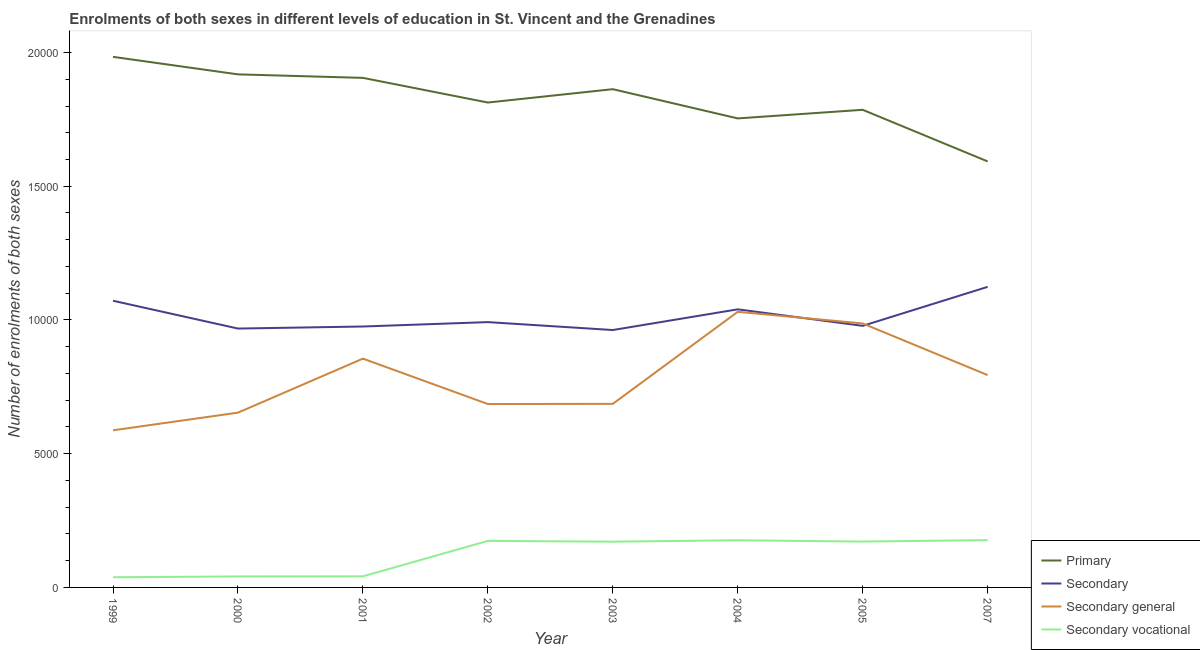How many different coloured lines are there?
Offer a terse response. 4. Does the line corresponding to number of enrolments in primary education intersect with the line corresponding to number of enrolments in secondary general education?
Offer a very short reply. No. What is the number of enrolments in secondary education in 1999?
Provide a succinct answer. 1.07e+04. Across all years, what is the maximum number of enrolments in primary education?
Make the answer very short. 1.98e+04. Across all years, what is the minimum number of enrolments in secondary vocational education?
Your answer should be compact. 380. In which year was the number of enrolments in secondary general education maximum?
Ensure brevity in your answer.  2004. In which year was the number of enrolments in secondary vocational education minimum?
Make the answer very short. 1999. What is the total number of enrolments in primary education in the graph?
Offer a very short reply. 1.46e+05. What is the difference between the number of enrolments in primary education in 2004 and that in 2005?
Your answer should be compact. -322. What is the difference between the number of enrolments in secondary general education in 2002 and the number of enrolments in primary education in 2004?
Your response must be concise. -1.07e+04. What is the average number of enrolments in secondary education per year?
Provide a short and direct response. 1.01e+04. In the year 2000, what is the difference between the number of enrolments in primary education and number of enrolments in secondary general education?
Your answer should be very brief. 1.26e+04. In how many years, is the number of enrolments in primary education greater than 4000?
Make the answer very short. 8. What is the ratio of the number of enrolments in secondary general education in 1999 to that in 2000?
Offer a very short reply. 0.9. What is the difference between the highest and the second highest number of enrolments in primary education?
Your response must be concise. 655. What is the difference between the highest and the lowest number of enrolments in secondary general education?
Your answer should be very brief. 4430. In how many years, is the number of enrolments in secondary general education greater than the average number of enrolments in secondary general education taken over all years?
Provide a succinct answer. 4. Is the sum of the number of enrolments in primary education in 1999 and 2004 greater than the maximum number of enrolments in secondary education across all years?
Provide a succinct answer. Yes. Is it the case that in every year, the sum of the number of enrolments in primary education and number of enrolments in secondary education is greater than the number of enrolments in secondary general education?
Your answer should be compact. Yes. Does the number of enrolments in primary education monotonically increase over the years?
Give a very brief answer. No. How many years are there in the graph?
Offer a very short reply. 8. Does the graph contain any zero values?
Keep it short and to the point. No. Does the graph contain grids?
Ensure brevity in your answer.  No. How many legend labels are there?
Your response must be concise. 4. What is the title of the graph?
Offer a very short reply. Enrolments of both sexes in different levels of education in St. Vincent and the Grenadines. Does "Negligence towards children" appear as one of the legend labels in the graph?
Provide a short and direct response. No. What is the label or title of the Y-axis?
Provide a succinct answer. Number of enrolments of both sexes. What is the Number of enrolments of both sexes of Primary in 1999?
Offer a terse response. 1.98e+04. What is the Number of enrolments of both sexes of Secondary in 1999?
Make the answer very short. 1.07e+04. What is the Number of enrolments of both sexes in Secondary general in 1999?
Offer a terse response. 5875. What is the Number of enrolments of both sexes of Secondary vocational in 1999?
Keep it short and to the point. 380. What is the Number of enrolments of both sexes of Primary in 2000?
Your answer should be compact. 1.92e+04. What is the Number of enrolments of both sexes of Secondary in 2000?
Your answer should be very brief. 9679. What is the Number of enrolments of both sexes in Secondary general in 2000?
Your response must be concise. 6535. What is the Number of enrolments of both sexes in Secondary vocational in 2000?
Provide a short and direct response. 411. What is the Number of enrolments of both sexes of Primary in 2001?
Your response must be concise. 1.91e+04. What is the Number of enrolments of both sexes of Secondary in 2001?
Offer a very short reply. 9756. What is the Number of enrolments of both sexes in Secondary general in 2001?
Make the answer very short. 8555. What is the Number of enrolments of both sexes in Secondary vocational in 2001?
Provide a short and direct response. 414. What is the Number of enrolments of both sexes of Primary in 2002?
Your answer should be very brief. 1.81e+04. What is the Number of enrolments of both sexes in Secondary in 2002?
Provide a succinct answer. 9920. What is the Number of enrolments of both sexes in Secondary general in 2002?
Keep it short and to the point. 6857. What is the Number of enrolments of both sexes of Secondary vocational in 2002?
Give a very brief answer. 1740. What is the Number of enrolments of both sexes in Primary in 2003?
Ensure brevity in your answer.  1.86e+04. What is the Number of enrolments of both sexes of Secondary in 2003?
Provide a short and direct response. 9624. What is the Number of enrolments of both sexes in Secondary general in 2003?
Offer a very short reply. 6864. What is the Number of enrolments of both sexes of Secondary vocational in 2003?
Give a very brief answer. 1711. What is the Number of enrolments of both sexes in Primary in 2004?
Your response must be concise. 1.75e+04. What is the Number of enrolments of both sexes in Secondary in 2004?
Ensure brevity in your answer.  1.04e+04. What is the Number of enrolments of both sexes in Secondary general in 2004?
Ensure brevity in your answer.  1.03e+04. What is the Number of enrolments of both sexes in Secondary vocational in 2004?
Provide a short and direct response. 1763. What is the Number of enrolments of both sexes in Primary in 2005?
Ensure brevity in your answer.  1.79e+04. What is the Number of enrolments of both sexes of Secondary in 2005?
Your answer should be compact. 9780. What is the Number of enrolments of both sexes in Secondary general in 2005?
Your answer should be compact. 9870. What is the Number of enrolments of both sexes in Secondary vocational in 2005?
Offer a terse response. 1715. What is the Number of enrolments of both sexes of Primary in 2007?
Offer a terse response. 1.59e+04. What is the Number of enrolments of both sexes in Secondary in 2007?
Your response must be concise. 1.12e+04. What is the Number of enrolments of both sexes of Secondary general in 2007?
Provide a succinct answer. 7939. What is the Number of enrolments of both sexes in Secondary vocational in 2007?
Ensure brevity in your answer.  1769. Across all years, what is the maximum Number of enrolments of both sexes in Primary?
Provide a short and direct response. 1.98e+04. Across all years, what is the maximum Number of enrolments of both sexes in Secondary?
Offer a terse response. 1.12e+04. Across all years, what is the maximum Number of enrolments of both sexes of Secondary general?
Provide a short and direct response. 1.03e+04. Across all years, what is the maximum Number of enrolments of both sexes in Secondary vocational?
Give a very brief answer. 1769. Across all years, what is the minimum Number of enrolments of both sexes of Primary?
Provide a succinct answer. 1.59e+04. Across all years, what is the minimum Number of enrolments of both sexes in Secondary?
Give a very brief answer. 9624. Across all years, what is the minimum Number of enrolments of both sexes of Secondary general?
Your response must be concise. 5875. Across all years, what is the minimum Number of enrolments of both sexes of Secondary vocational?
Give a very brief answer. 380. What is the total Number of enrolments of both sexes in Primary in the graph?
Provide a short and direct response. 1.46e+05. What is the total Number of enrolments of both sexes of Secondary in the graph?
Provide a succinct answer. 8.11e+04. What is the total Number of enrolments of both sexes in Secondary general in the graph?
Provide a short and direct response. 6.28e+04. What is the total Number of enrolments of both sexes in Secondary vocational in the graph?
Ensure brevity in your answer.  9903. What is the difference between the Number of enrolments of both sexes in Primary in 1999 and that in 2000?
Make the answer very short. 655. What is the difference between the Number of enrolments of both sexes in Secondary in 1999 and that in 2000?
Give a very brief answer. 1040. What is the difference between the Number of enrolments of both sexes of Secondary general in 1999 and that in 2000?
Offer a terse response. -660. What is the difference between the Number of enrolments of both sexes in Secondary vocational in 1999 and that in 2000?
Provide a short and direct response. -31. What is the difference between the Number of enrolments of both sexes of Primary in 1999 and that in 2001?
Make the answer very short. 786. What is the difference between the Number of enrolments of both sexes of Secondary in 1999 and that in 2001?
Provide a short and direct response. 963. What is the difference between the Number of enrolments of both sexes of Secondary general in 1999 and that in 2001?
Your answer should be compact. -2680. What is the difference between the Number of enrolments of both sexes in Secondary vocational in 1999 and that in 2001?
Give a very brief answer. -34. What is the difference between the Number of enrolments of both sexes of Primary in 1999 and that in 2002?
Offer a very short reply. 1708. What is the difference between the Number of enrolments of both sexes in Secondary in 1999 and that in 2002?
Your answer should be compact. 799. What is the difference between the Number of enrolments of both sexes of Secondary general in 1999 and that in 2002?
Provide a short and direct response. -982. What is the difference between the Number of enrolments of both sexes in Secondary vocational in 1999 and that in 2002?
Ensure brevity in your answer.  -1360. What is the difference between the Number of enrolments of both sexes in Primary in 1999 and that in 2003?
Ensure brevity in your answer.  1209. What is the difference between the Number of enrolments of both sexes of Secondary in 1999 and that in 2003?
Give a very brief answer. 1095. What is the difference between the Number of enrolments of both sexes of Secondary general in 1999 and that in 2003?
Offer a very short reply. -989. What is the difference between the Number of enrolments of both sexes in Secondary vocational in 1999 and that in 2003?
Provide a short and direct response. -1331. What is the difference between the Number of enrolments of both sexes in Primary in 1999 and that in 2004?
Ensure brevity in your answer.  2302. What is the difference between the Number of enrolments of both sexes in Secondary in 1999 and that in 2004?
Your response must be concise. 321. What is the difference between the Number of enrolments of both sexes in Secondary general in 1999 and that in 2004?
Give a very brief answer. -4430. What is the difference between the Number of enrolments of both sexes in Secondary vocational in 1999 and that in 2004?
Keep it short and to the point. -1383. What is the difference between the Number of enrolments of both sexes in Primary in 1999 and that in 2005?
Give a very brief answer. 1980. What is the difference between the Number of enrolments of both sexes in Secondary in 1999 and that in 2005?
Keep it short and to the point. 939. What is the difference between the Number of enrolments of both sexes in Secondary general in 1999 and that in 2005?
Provide a short and direct response. -3995. What is the difference between the Number of enrolments of both sexes of Secondary vocational in 1999 and that in 2005?
Offer a very short reply. -1335. What is the difference between the Number of enrolments of both sexes in Primary in 1999 and that in 2007?
Your response must be concise. 3910. What is the difference between the Number of enrolments of both sexes of Secondary in 1999 and that in 2007?
Offer a very short reply. -519. What is the difference between the Number of enrolments of both sexes in Secondary general in 1999 and that in 2007?
Keep it short and to the point. -2064. What is the difference between the Number of enrolments of both sexes of Secondary vocational in 1999 and that in 2007?
Give a very brief answer. -1389. What is the difference between the Number of enrolments of both sexes in Primary in 2000 and that in 2001?
Your answer should be compact. 131. What is the difference between the Number of enrolments of both sexes in Secondary in 2000 and that in 2001?
Your answer should be very brief. -77. What is the difference between the Number of enrolments of both sexes in Secondary general in 2000 and that in 2001?
Ensure brevity in your answer.  -2020. What is the difference between the Number of enrolments of both sexes in Secondary vocational in 2000 and that in 2001?
Give a very brief answer. -3. What is the difference between the Number of enrolments of both sexes in Primary in 2000 and that in 2002?
Give a very brief answer. 1053. What is the difference between the Number of enrolments of both sexes in Secondary in 2000 and that in 2002?
Your answer should be compact. -241. What is the difference between the Number of enrolments of both sexes in Secondary general in 2000 and that in 2002?
Keep it short and to the point. -322. What is the difference between the Number of enrolments of both sexes of Secondary vocational in 2000 and that in 2002?
Your response must be concise. -1329. What is the difference between the Number of enrolments of both sexes of Primary in 2000 and that in 2003?
Offer a very short reply. 554. What is the difference between the Number of enrolments of both sexes in Secondary in 2000 and that in 2003?
Provide a short and direct response. 55. What is the difference between the Number of enrolments of both sexes of Secondary general in 2000 and that in 2003?
Ensure brevity in your answer.  -329. What is the difference between the Number of enrolments of both sexes of Secondary vocational in 2000 and that in 2003?
Provide a succinct answer. -1300. What is the difference between the Number of enrolments of both sexes of Primary in 2000 and that in 2004?
Ensure brevity in your answer.  1647. What is the difference between the Number of enrolments of both sexes in Secondary in 2000 and that in 2004?
Make the answer very short. -719. What is the difference between the Number of enrolments of both sexes in Secondary general in 2000 and that in 2004?
Provide a succinct answer. -3770. What is the difference between the Number of enrolments of both sexes in Secondary vocational in 2000 and that in 2004?
Give a very brief answer. -1352. What is the difference between the Number of enrolments of both sexes of Primary in 2000 and that in 2005?
Your answer should be compact. 1325. What is the difference between the Number of enrolments of both sexes of Secondary in 2000 and that in 2005?
Ensure brevity in your answer.  -101. What is the difference between the Number of enrolments of both sexes in Secondary general in 2000 and that in 2005?
Your answer should be compact. -3335. What is the difference between the Number of enrolments of both sexes in Secondary vocational in 2000 and that in 2005?
Make the answer very short. -1304. What is the difference between the Number of enrolments of both sexes of Primary in 2000 and that in 2007?
Your answer should be compact. 3255. What is the difference between the Number of enrolments of both sexes of Secondary in 2000 and that in 2007?
Offer a terse response. -1559. What is the difference between the Number of enrolments of both sexes of Secondary general in 2000 and that in 2007?
Provide a succinct answer. -1404. What is the difference between the Number of enrolments of both sexes of Secondary vocational in 2000 and that in 2007?
Ensure brevity in your answer.  -1358. What is the difference between the Number of enrolments of both sexes of Primary in 2001 and that in 2002?
Give a very brief answer. 922. What is the difference between the Number of enrolments of both sexes in Secondary in 2001 and that in 2002?
Give a very brief answer. -164. What is the difference between the Number of enrolments of both sexes of Secondary general in 2001 and that in 2002?
Provide a short and direct response. 1698. What is the difference between the Number of enrolments of both sexes of Secondary vocational in 2001 and that in 2002?
Your response must be concise. -1326. What is the difference between the Number of enrolments of both sexes in Primary in 2001 and that in 2003?
Make the answer very short. 423. What is the difference between the Number of enrolments of both sexes in Secondary in 2001 and that in 2003?
Offer a terse response. 132. What is the difference between the Number of enrolments of both sexes in Secondary general in 2001 and that in 2003?
Provide a short and direct response. 1691. What is the difference between the Number of enrolments of both sexes in Secondary vocational in 2001 and that in 2003?
Give a very brief answer. -1297. What is the difference between the Number of enrolments of both sexes of Primary in 2001 and that in 2004?
Provide a succinct answer. 1516. What is the difference between the Number of enrolments of both sexes in Secondary in 2001 and that in 2004?
Offer a terse response. -642. What is the difference between the Number of enrolments of both sexes in Secondary general in 2001 and that in 2004?
Provide a short and direct response. -1750. What is the difference between the Number of enrolments of both sexes of Secondary vocational in 2001 and that in 2004?
Your answer should be compact. -1349. What is the difference between the Number of enrolments of both sexes of Primary in 2001 and that in 2005?
Your answer should be very brief. 1194. What is the difference between the Number of enrolments of both sexes in Secondary in 2001 and that in 2005?
Give a very brief answer. -24. What is the difference between the Number of enrolments of both sexes of Secondary general in 2001 and that in 2005?
Provide a succinct answer. -1315. What is the difference between the Number of enrolments of both sexes of Secondary vocational in 2001 and that in 2005?
Your answer should be very brief. -1301. What is the difference between the Number of enrolments of both sexes in Primary in 2001 and that in 2007?
Keep it short and to the point. 3124. What is the difference between the Number of enrolments of both sexes in Secondary in 2001 and that in 2007?
Your answer should be compact. -1482. What is the difference between the Number of enrolments of both sexes of Secondary general in 2001 and that in 2007?
Provide a succinct answer. 616. What is the difference between the Number of enrolments of both sexes in Secondary vocational in 2001 and that in 2007?
Your answer should be very brief. -1355. What is the difference between the Number of enrolments of both sexes in Primary in 2002 and that in 2003?
Offer a terse response. -499. What is the difference between the Number of enrolments of both sexes in Secondary in 2002 and that in 2003?
Give a very brief answer. 296. What is the difference between the Number of enrolments of both sexes in Secondary general in 2002 and that in 2003?
Provide a short and direct response. -7. What is the difference between the Number of enrolments of both sexes of Primary in 2002 and that in 2004?
Your answer should be very brief. 594. What is the difference between the Number of enrolments of both sexes in Secondary in 2002 and that in 2004?
Your answer should be compact. -478. What is the difference between the Number of enrolments of both sexes of Secondary general in 2002 and that in 2004?
Provide a succinct answer. -3448. What is the difference between the Number of enrolments of both sexes in Secondary vocational in 2002 and that in 2004?
Offer a very short reply. -23. What is the difference between the Number of enrolments of both sexes of Primary in 2002 and that in 2005?
Offer a very short reply. 272. What is the difference between the Number of enrolments of both sexes of Secondary in 2002 and that in 2005?
Your answer should be compact. 140. What is the difference between the Number of enrolments of both sexes in Secondary general in 2002 and that in 2005?
Your response must be concise. -3013. What is the difference between the Number of enrolments of both sexes of Secondary vocational in 2002 and that in 2005?
Make the answer very short. 25. What is the difference between the Number of enrolments of both sexes of Primary in 2002 and that in 2007?
Your response must be concise. 2202. What is the difference between the Number of enrolments of both sexes of Secondary in 2002 and that in 2007?
Make the answer very short. -1318. What is the difference between the Number of enrolments of both sexes in Secondary general in 2002 and that in 2007?
Offer a terse response. -1082. What is the difference between the Number of enrolments of both sexes of Secondary vocational in 2002 and that in 2007?
Make the answer very short. -29. What is the difference between the Number of enrolments of both sexes in Primary in 2003 and that in 2004?
Your response must be concise. 1093. What is the difference between the Number of enrolments of both sexes of Secondary in 2003 and that in 2004?
Provide a succinct answer. -774. What is the difference between the Number of enrolments of both sexes of Secondary general in 2003 and that in 2004?
Keep it short and to the point. -3441. What is the difference between the Number of enrolments of both sexes in Secondary vocational in 2003 and that in 2004?
Offer a very short reply. -52. What is the difference between the Number of enrolments of both sexes in Primary in 2003 and that in 2005?
Your response must be concise. 771. What is the difference between the Number of enrolments of both sexes of Secondary in 2003 and that in 2005?
Provide a succinct answer. -156. What is the difference between the Number of enrolments of both sexes in Secondary general in 2003 and that in 2005?
Your response must be concise. -3006. What is the difference between the Number of enrolments of both sexes in Secondary vocational in 2003 and that in 2005?
Give a very brief answer. -4. What is the difference between the Number of enrolments of both sexes of Primary in 2003 and that in 2007?
Your answer should be very brief. 2701. What is the difference between the Number of enrolments of both sexes in Secondary in 2003 and that in 2007?
Provide a short and direct response. -1614. What is the difference between the Number of enrolments of both sexes in Secondary general in 2003 and that in 2007?
Provide a short and direct response. -1075. What is the difference between the Number of enrolments of both sexes of Secondary vocational in 2003 and that in 2007?
Ensure brevity in your answer.  -58. What is the difference between the Number of enrolments of both sexes of Primary in 2004 and that in 2005?
Provide a short and direct response. -322. What is the difference between the Number of enrolments of both sexes in Secondary in 2004 and that in 2005?
Your answer should be very brief. 618. What is the difference between the Number of enrolments of both sexes of Secondary general in 2004 and that in 2005?
Provide a succinct answer. 435. What is the difference between the Number of enrolments of both sexes of Secondary vocational in 2004 and that in 2005?
Ensure brevity in your answer.  48. What is the difference between the Number of enrolments of both sexes of Primary in 2004 and that in 2007?
Provide a short and direct response. 1608. What is the difference between the Number of enrolments of both sexes in Secondary in 2004 and that in 2007?
Provide a short and direct response. -840. What is the difference between the Number of enrolments of both sexes of Secondary general in 2004 and that in 2007?
Your response must be concise. 2366. What is the difference between the Number of enrolments of both sexes in Primary in 2005 and that in 2007?
Keep it short and to the point. 1930. What is the difference between the Number of enrolments of both sexes in Secondary in 2005 and that in 2007?
Your response must be concise. -1458. What is the difference between the Number of enrolments of both sexes of Secondary general in 2005 and that in 2007?
Your answer should be compact. 1931. What is the difference between the Number of enrolments of both sexes in Secondary vocational in 2005 and that in 2007?
Your answer should be very brief. -54. What is the difference between the Number of enrolments of both sexes in Primary in 1999 and the Number of enrolments of both sexes in Secondary in 2000?
Make the answer very short. 1.02e+04. What is the difference between the Number of enrolments of both sexes in Primary in 1999 and the Number of enrolments of both sexes in Secondary general in 2000?
Provide a short and direct response. 1.33e+04. What is the difference between the Number of enrolments of both sexes in Primary in 1999 and the Number of enrolments of both sexes in Secondary vocational in 2000?
Your answer should be very brief. 1.94e+04. What is the difference between the Number of enrolments of both sexes of Secondary in 1999 and the Number of enrolments of both sexes of Secondary general in 2000?
Offer a very short reply. 4184. What is the difference between the Number of enrolments of both sexes of Secondary in 1999 and the Number of enrolments of both sexes of Secondary vocational in 2000?
Offer a very short reply. 1.03e+04. What is the difference between the Number of enrolments of both sexes in Secondary general in 1999 and the Number of enrolments of both sexes in Secondary vocational in 2000?
Your response must be concise. 5464. What is the difference between the Number of enrolments of both sexes in Primary in 1999 and the Number of enrolments of both sexes in Secondary in 2001?
Provide a succinct answer. 1.01e+04. What is the difference between the Number of enrolments of both sexes in Primary in 1999 and the Number of enrolments of both sexes in Secondary general in 2001?
Your answer should be compact. 1.13e+04. What is the difference between the Number of enrolments of both sexes of Primary in 1999 and the Number of enrolments of both sexes of Secondary vocational in 2001?
Keep it short and to the point. 1.94e+04. What is the difference between the Number of enrolments of both sexes in Secondary in 1999 and the Number of enrolments of both sexes in Secondary general in 2001?
Your response must be concise. 2164. What is the difference between the Number of enrolments of both sexes of Secondary in 1999 and the Number of enrolments of both sexes of Secondary vocational in 2001?
Provide a short and direct response. 1.03e+04. What is the difference between the Number of enrolments of both sexes in Secondary general in 1999 and the Number of enrolments of both sexes in Secondary vocational in 2001?
Your answer should be very brief. 5461. What is the difference between the Number of enrolments of both sexes of Primary in 1999 and the Number of enrolments of both sexes of Secondary in 2002?
Give a very brief answer. 9918. What is the difference between the Number of enrolments of both sexes of Primary in 1999 and the Number of enrolments of both sexes of Secondary general in 2002?
Ensure brevity in your answer.  1.30e+04. What is the difference between the Number of enrolments of both sexes of Primary in 1999 and the Number of enrolments of both sexes of Secondary vocational in 2002?
Your answer should be very brief. 1.81e+04. What is the difference between the Number of enrolments of both sexes of Secondary in 1999 and the Number of enrolments of both sexes of Secondary general in 2002?
Your answer should be very brief. 3862. What is the difference between the Number of enrolments of both sexes of Secondary in 1999 and the Number of enrolments of both sexes of Secondary vocational in 2002?
Your answer should be very brief. 8979. What is the difference between the Number of enrolments of both sexes of Secondary general in 1999 and the Number of enrolments of both sexes of Secondary vocational in 2002?
Offer a very short reply. 4135. What is the difference between the Number of enrolments of both sexes in Primary in 1999 and the Number of enrolments of both sexes in Secondary in 2003?
Your answer should be very brief. 1.02e+04. What is the difference between the Number of enrolments of both sexes in Primary in 1999 and the Number of enrolments of both sexes in Secondary general in 2003?
Give a very brief answer. 1.30e+04. What is the difference between the Number of enrolments of both sexes in Primary in 1999 and the Number of enrolments of both sexes in Secondary vocational in 2003?
Offer a terse response. 1.81e+04. What is the difference between the Number of enrolments of both sexes of Secondary in 1999 and the Number of enrolments of both sexes of Secondary general in 2003?
Offer a very short reply. 3855. What is the difference between the Number of enrolments of both sexes in Secondary in 1999 and the Number of enrolments of both sexes in Secondary vocational in 2003?
Provide a succinct answer. 9008. What is the difference between the Number of enrolments of both sexes of Secondary general in 1999 and the Number of enrolments of both sexes of Secondary vocational in 2003?
Your response must be concise. 4164. What is the difference between the Number of enrolments of both sexes in Primary in 1999 and the Number of enrolments of both sexes in Secondary in 2004?
Provide a succinct answer. 9440. What is the difference between the Number of enrolments of both sexes of Primary in 1999 and the Number of enrolments of both sexes of Secondary general in 2004?
Offer a terse response. 9533. What is the difference between the Number of enrolments of both sexes in Primary in 1999 and the Number of enrolments of both sexes in Secondary vocational in 2004?
Provide a succinct answer. 1.81e+04. What is the difference between the Number of enrolments of both sexes in Secondary in 1999 and the Number of enrolments of both sexes in Secondary general in 2004?
Provide a succinct answer. 414. What is the difference between the Number of enrolments of both sexes of Secondary in 1999 and the Number of enrolments of both sexes of Secondary vocational in 2004?
Give a very brief answer. 8956. What is the difference between the Number of enrolments of both sexes of Secondary general in 1999 and the Number of enrolments of both sexes of Secondary vocational in 2004?
Make the answer very short. 4112. What is the difference between the Number of enrolments of both sexes in Primary in 1999 and the Number of enrolments of both sexes in Secondary in 2005?
Your answer should be compact. 1.01e+04. What is the difference between the Number of enrolments of both sexes of Primary in 1999 and the Number of enrolments of both sexes of Secondary general in 2005?
Your answer should be compact. 9968. What is the difference between the Number of enrolments of both sexes of Primary in 1999 and the Number of enrolments of both sexes of Secondary vocational in 2005?
Keep it short and to the point. 1.81e+04. What is the difference between the Number of enrolments of both sexes of Secondary in 1999 and the Number of enrolments of both sexes of Secondary general in 2005?
Your response must be concise. 849. What is the difference between the Number of enrolments of both sexes in Secondary in 1999 and the Number of enrolments of both sexes in Secondary vocational in 2005?
Give a very brief answer. 9004. What is the difference between the Number of enrolments of both sexes of Secondary general in 1999 and the Number of enrolments of both sexes of Secondary vocational in 2005?
Your response must be concise. 4160. What is the difference between the Number of enrolments of both sexes in Primary in 1999 and the Number of enrolments of both sexes in Secondary in 2007?
Provide a succinct answer. 8600. What is the difference between the Number of enrolments of both sexes of Primary in 1999 and the Number of enrolments of both sexes of Secondary general in 2007?
Keep it short and to the point. 1.19e+04. What is the difference between the Number of enrolments of both sexes of Primary in 1999 and the Number of enrolments of both sexes of Secondary vocational in 2007?
Give a very brief answer. 1.81e+04. What is the difference between the Number of enrolments of both sexes of Secondary in 1999 and the Number of enrolments of both sexes of Secondary general in 2007?
Make the answer very short. 2780. What is the difference between the Number of enrolments of both sexes of Secondary in 1999 and the Number of enrolments of both sexes of Secondary vocational in 2007?
Provide a succinct answer. 8950. What is the difference between the Number of enrolments of both sexes in Secondary general in 1999 and the Number of enrolments of both sexes in Secondary vocational in 2007?
Provide a short and direct response. 4106. What is the difference between the Number of enrolments of both sexes in Primary in 2000 and the Number of enrolments of both sexes in Secondary in 2001?
Your answer should be compact. 9427. What is the difference between the Number of enrolments of both sexes in Primary in 2000 and the Number of enrolments of both sexes in Secondary general in 2001?
Offer a very short reply. 1.06e+04. What is the difference between the Number of enrolments of both sexes in Primary in 2000 and the Number of enrolments of both sexes in Secondary vocational in 2001?
Provide a short and direct response. 1.88e+04. What is the difference between the Number of enrolments of both sexes in Secondary in 2000 and the Number of enrolments of both sexes in Secondary general in 2001?
Make the answer very short. 1124. What is the difference between the Number of enrolments of both sexes in Secondary in 2000 and the Number of enrolments of both sexes in Secondary vocational in 2001?
Keep it short and to the point. 9265. What is the difference between the Number of enrolments of both sexes of Secondary general in 2000 and the Number of enrolments of both sexes of Secondary vocational in 2001?
Your answer should be compact. 6121. What is the difference between the Number of enrolments of both sexes of Primary in 2000 and the Number of enrolments of both sexes of Secondary in 2002?
Offer a very short reply. 9263. What is the difference between the Number of enrolments of both sexes of Primary in 2000 and the Number of enrolments of both sexes of Secondary general in 2002?
Keep it short and to the point. 1.23e+04. What is the difference between the Number of enrolments of both sexes in Primary in 2000 and the Number of enrolments of both sexes in Secondary vocational in 2002?
Keep it short and to the point. 1.74e+04. What is the difference between the Number of enrolments of both sexes in Secondary in 2000 and the Number of enrolments of both sexes in Secondary general in 2002?
Provide a succinct answer. 2822. What is the difference between the Number of enrolments of both sexes of Secondary in 2000 and the Number of enrolments of both sexes of Secondary vocational in 2002?
Your answer should be very brief. 7939. What is the difference between the Number of enrolments of both sexes in Secondary general in 2000 and the Number of enrolments of both sexes in Secondary vocational in 2002?
Your response must be concise. 4795. What is the difference between the Number of enrolments of both sexes of Primary in 2000 and the Number of enrolments of both sexes of Secondary in 2003?
Give a very brief answer. 9559. What is the difference between the Number of enrolments of both sexes of Primary in 2000 and the Number of enrolments of both sexes of Secondary general in 2003?
Your response must be concise. 1.23e+04. What is the difference between the Number of enrolments of both sexes of Primary in 2000 and the Number of enrolments of both sexes of Secondary vocational in 2003?
Make the answer very short. 1.75e+04. What is the difference between the Number of enrolments of both sexes of Secondary in 2000 and the Number of enrolments of both sexes of Secondary general in 2003?
Ensure brevity in your answer.  2815. What is the difference between the Number of enrolments of both sexes in Secondary in 2000 and the Number of enrolments of both sexes in Secondary vocational in 2003?
Your answer should be compact. 7968. What is the difference between the Number of enrolments of both sexes in Secondary general in 2000 and the Number of enrolments of both sexes in Secondary vocational in 2003?
Offer a very short reply. 4824. What is the difference between the Number of enrolments of both sexes in Primary in 2000 and the Number of enrolments of both sexes in Secondary in 2004?
Provide a succinct answer. 8785. What is the difference between the Number of enrolments of both sexes in Primary in 2000 and the Number of enrolments of both sexes in Secondary general in 2004?
Offer a very short reply. 8878. What is the difference between the Number of enrolments of both sexes in Primary in 2000 and the Number of enrolments of both sexes in Secondary vocational in 2004?
Your answer should be compact. 1.74e+04. What is the difference between the Number of enrolments of both sexes in Secondary in 2000 and the Number of enrolments of both sexes in Secondary general in 2004?
Provide a succinct answer. -626. What is the difference between the Number of enrolments of both sexes of Secondary in 2000 and the Number of enrolments of both sexes of Secondary vocational in 2004?
Provide a succinct answer. 7916. What is the difference between the Number of enrolments of both sexes in Secondary general in 2000 and the Number of enrolments of both sexes in Secondary vocational in 2004?
Keep it short and to the point. 4772. What is the difference between the Number of enrolments of both sexes of Primary in 2000 and the Number of enrolments of both sexes of Secondary in 2005?
Keep it short and to the point. 9403. What is the difference between the Number of enrolments of both sexes of Primary in 2000 and the Number of enrolments of both sexes of Secondary general in 2005?
Make the answer very short. 9313. What is the difference between the Number of enrolments of both sexes in Primary in 2000 and the Number of enrolments of both sexes in Secondary vocational in 2005?
Give a very brief answer. 1.75e+04. What is the difference between the Number of enrolments of both sexes of Secondary in 2000 and the Number of enrolments of both sexes of Secondary general in 2005?
Ensure brevity in your answer.  -191. What is the difference between the Number of enrolments of both sexes in Secondary in 2000 and the Number of enrolments of both sexes in Secondary vocational in 2005?
Offer a very short reply. 7964. What is the difference between the Number of enrolments of both sexes of Secondary general in 2000 and the Number of enrolments of both sexes of Secondary vocational in 2005?
Give a very brief answer. 4820. What is the difference between the Number of enrolments of both sexes in Primary in 2000 and the Number of enrolments of both sexes in Secondary in 2007?
Ensure brevity in your answer.  7945. What is the difference between the Number of enrolments of both sexes in Primary in 2000 and the Number of enrolments of both sexes in Secondary general in 2007?
Your answer should be very brief. 1.12e+04. What is the difference between the Number of enrolments of both sexes of Primary in 2000 and the Number of enrolments of both sexes of Secondary vocational in 2007?
Give a very brief answer. 1.74e+04. What is the difference between the Number of enrolments of both sexes in Secondary in 2000 and the Number of enrolments of both sexes in Secondary general in 2007?
Provide a short and direct response. 1740. What is the difference between the Number of enrolments of both sexes in Secondary in 2000 and the Number of enrolments of both sexes in Secondary vocational in 2007?
Provide a short and direct response. 7910. What is the difference between the Number of enrolments of both sexes in Secondary general in 2000 and the Number of enrolments of both sexes in Secondary vocational in 2007?
Your answer should be compact. 4766. What is the difference between the Number of enrolments of both sexes in Primary in 2001 and the Number of enrolments of both sexes in Secondary in 2002?
Offer a terse response. 9132. What is the difference between the Number of enrolments of both sexes of Primary in 2001 and the Number of enrolments of both sexes of Secondary general in 2002?
Offer a terse response. 1.22e+04. What is the difference between the Number of enrolments of both sexes in Primary in 2001 and the Number of enrolments of both sexes in Secondary vocational in 2002?
Give a very brief answer. 1.73e+04. What is the difference between the Number of enrolments of both sexes of Secondary in 2001 and the Number of enrolments of both sexes of Secondary general in 2002?
Provide a succinct answer. 2899. What is the difference between the Number of enrolments of both sexes of Secondary in 2001 and the Number of enrolments of both sexes of Secondary vocational in 2002?
Provide a succinct answer. 8016. What is the difference between the Number of enrolments of both sexes of Secondary general in 2001 and the Number of enrolments of both sexes of Secondary vocational in 2002?
Make the answer very short. 6815. What is the difference between the Number of enrolments of both sexes of Primary in 2001 and the Number of enrolments of both sexes of Secondary in 2003?
Your answer should be compact. 9428. What is the difference between the Number of enrolments of both sexes of Primary in 2001 and the Number of enrolments of both sexes of Secondary general in 2003?
Provide a short and direct response. 1.22e+04. What is the difference between the Number of enrolments of both sexes of Primary in 2001 and the Number of enrolments of both sexes of Secondary vocational in 2003?
Ensure brevity in your answer.  1.73e+04. What is the difference between the Number of enrolments of both sexes in Secondary in 2001 and the Number of enrolments of both sexes in Secondary general in 2003?
Your answer should be compact. 2892. What is the difference between the Number of enrolments of both sexes of Secondary in 2001 and the Number of enrolments of both sexes of Secondary vocational in 2003?
Ensure brevity in your answer.  8045. What is the difference between the Number of enrolments of both sexes of Secondary general in 2001 and the Number of enrolments of both sexes of Secondary vocational in 2003?
Make the answer very short. 6844. What is the difference between the Number of enrolments of both sexes of Primary in 2001 and the Number of enrolments of both sexes of Secondary in 2004?
Ensure brevity in your answer.  8654. What is the difference between the Number of enrolments of both sexes in Primary in 2001 and the Number of enrolments of both sexes in Secondary general in 2004?
Give a very brief answer. 8747. What is the difference between the Number of enrolments of both sexes in Primary in 2001 and the Number of enrolments of both sexes in Secondary vocational in 2004?
Ensure brevity in your answer.  1.73e+04. What is the difference between the Number of enrolments of both sexes of Secondary in 2001 and the Number of enrolments of both sexes of Secondary general in 2004?
Your answer should be very brief. -549. What is the difference between the Number of enrolments of both sexes in Secondary in 2001 and the Number of enrolments of both sexes in Secondary vocational in 2004?
Ensure brevity in your answer.  7993. What is the difference between the Number of enrolments of both sexes in Secondary general in 2001 and the Number of enrolments of both sexes in Secondary vocational in 2004?
Offer a terse response. 6792. What is the difference between the Number of enrolments of both sexes of Primary in 2001 and the Number of enrolments of both sexes of Secondary in 2005?
Keep it short and to the point. 9272. What is the difference between the Number of enrolments of both sexes in Primary in 2001 and the Number of enrolments of both sexes in Secondary general in 2005?
Keep it short and to the point. 9182. What is the difference between the Number of enrolments of both sexes in Primary in 2001 and the Number of enrolments of both sexes in Secondary vocational in 2005?
Provide a short and direct response. 1.73e+04. What is the difference between the Number of enrolments of both sexes of Secondary in 2001 and the Number of enrolments of both sexes of Secondary general in 2005?
Ensure brevity in your answer.  -114. What is the difference between the Number of enrolments of both sexes in Secondary in 2001 and the Number of enrolments of both sexes in Secondary vocational in 2005?
Ensure brevity in your answer.  8041. What is the difference between the Number of enrolments of both sexes of Secondary general in 2001 and the Number of enrolments of both sexes of Secondary vocational in 2005?
Ensure brevity in your answer.  6840. What is the difference between the Number of enrolments of both sexes of Primary in 2001 and the Number of enrolments of both sexes of Secondary in 2007?
Make the answer very short. 7814. What is the difference between the Number of enrolments of both sexes in Primary in 2001 and the Number of enrolments of both sexes in Secondary general in 2007?
Offer a very short reply. 1.11e+04. What is the difference between the Number of enrolments of both sexes in Primary in 2001 and the Number of enrolments of both sexes in Secondary vocational in 2007?
Provide a succinct answer. 1.73e+04. What is the difference between the Number of enrolments of both sexes of Secondary in 2001 and the Number of enrolments of both sexes of Secondary general in 2007?
Your answer should be compact. 1817. What is the difference between the Number of enrolments of both sexes in Secondary in 2001 and the Number of enrolments of both sexes in Secondary vocational in 2007?
Your answer should be very brief. 7987. What is the difference between the Number of enrolments of both sexes of Secondary general in 2001 and the Number of enrolments of both sexes of Secondary vocational in 2007?
Ensure brevity in your answer.  6786. What is the difference between the Number of enrolments of both sexes of Primary in 2002 and the Number of enrolments of both sexes of Secondary in 2003?
Keep it short and to the point. 8506. What is the difference between the Number of enrolments of both sexes in Primary in 2002 and the Number of enrolments of both sexes in Secondary general in 2003?
Give a very brief answer. 1.13e+04. What is the difference between the Number of enrolments of both sexes in Primary in 2002 and the Number of enrolments of both sexes in Secondary vocational in 2003?
Make the answer very short. 1.64e+04. What is the difference between the Number of enrolments of both sexes of Secondary in 2002 and the Number of enrolments of both sexes of Secondary general in 2003?
Your answer should be very brief. 3056. What is the difference between the Number of enrolments of both sexes in Secondary in 2002 and the Number of enrolments of both sexes in Secondary vocational in 2003?
Your answer should be very brief. 8209. What is the difference between the Number of enrolments of both sexes of Secondary general in 2002 and the Number of enrolments of both sexes of Secondary vocational in 2003?
Provide a short and direct response. 5146. What is the difference between the Number of enrolments of both sexes of Primary in 2002 and the Number of enrolments of both sexes of Secondary in 2004?
Offer a terse response. 7732. What is the difference between the Number of enrolments of both sexes in Primary in 2002 and the Number of enrolments of both sexes in Secondary general in 2004?
Your response must be concise. 7825. What is the difference between the Number of enrolments of both sexes of Primary in 2002 and the Number of enrolments of both sexes of Secondary vocational in 2004?
Offer a very short reply. 1.64e+04. What is the difference between the Number of enrolments of both sexes of Secondary in 2002 and the Number of enrolments of both sexes of Secondary general in 2004?
Provide a succinct answer. -385. What is the difference between the Number of enrolments of both sexes in Secondary in 2002 and the Number of enrolments of both sexes in Secondary vocational in 2004?
Ensure brevity in your answer.  8157. What is the difference between the Number of enrolments of both sexes of Secondary general in 2002 and the Number of enrolments of both sexes of Secondary vocational in 2004?
Offer a very short reply. 5094. What is the difference between the Number of enrolments of both sexes of Primary in 2002 and the Number of enrolments of both sexes of Secondary in 2005?
Provide a short and direct response. 8350. What is the difference between the Number of enrolments of both sexes of Primary in 2002 and the Number of enrolments of both sexes of Secondary general in 2005?
Offer a very short reply. 8260. What is the difference between the Number of enrolments of both sexes of Primary in 2002 and the Number of enrolments of both sexes of Secondary vocational in 2005?
Your response must be concise. 1.64e+04. What is the difference between the Number of enrolments of both sexes in Secondary in 2002 and the Number of enrolments of both sexes in Secondary vocational in 2005?
Keep it short and to the point. 8205. What is the difference between the Number of enrolments of both sexes of Secondary general in 2002 and the Number of enrolments of both sexes of Secondary vocational in 2005?
Offer a very short reply. 5142. What is the difference between the Number of enrolments of both sexes of Primary in 2002 and the Number of enrolments of both sexes of Secondary in 2007?
Your answer should be very brief. 6892. What is the difference between the Number of enrolments of both sexes of Primary in 2002 and the Number of enrolments of both sexes of Secondary general in 2007?
Ensure brevity in your answer.  1.02e+04. What is the difference between the Number of enrolments of both sexes of Primary in 2002 and the Number of enrolments of both sexes of Secondary vocational in 2007?
Your answer should be compact. 1.64e+04. What is the difference between the Number of enrolments of both sexes of Secondary in 2002 and the Number of enrolments of both sexes of Secondary general in 2007?
Offer a very short reply. 1981. What is the difference between the Number of enrolments of both sexes in Secondary in 2002 and the Number of enrolments of both sexes in Secondary vocational in 2007?
Provide a succinct answer. 8151. What is the difference between the Number of enrolments of both sexes in Secondary general in 2002 and the Number of enrolments of both sexes in Secondary vocational in 2007?
Keep it short and to the point. 5088. What is the difference between the Number of enrolments of both sexes of Primary in 2003 and the Number of enrolments of both sexes of Secondary in 2004?
Offer a very short reply. 8231. What is the difference between the Number of enrolments of both sexes in Primary in 2003 and the Number of enrolments of both sexes in Secondary general in 2004?
Provide a succinct answer. 8324. What is the difference between the Number of enrolments of both sexes in Primary in 2003 and the Number of enrolments of both sexes in Secondary vocational in 2004?
Make the answer very short. 1.69e+04. What is the difference between the Number of enrolments of both sexes in Secondary in 2003 and the Number of enrolments of both sexes in Secondary general in 2004?
Give a very brief answer. -681. What is the difference between the Number of enrolments of both sexes of Secondary in 2003 and the Number of enrolments of both sexes of Secondary vocational in 2004?
Your answer should be very brief. 7861. What is the difference between the Number of enrolments of both sexes in Secondary general in 2003 and the Number of enrolments of both sexes in Secondary vocational in 2004?
Offer a terse response. 5101. What is the difference between the Number of enrolments of both sexes in Primary in 2003 and the Number of enrolments of both sexes in Secondary in 2005?
Provide a succinct answer. 8849. What is the difference between the Number of enrolments of both sexes of Primary in 2003 and the Number of enrolments of both sexes of Secondary general in 2005?
Offer a very short reply. 8759. What is the difference between the Number of enrolments of both sexes in Primary in 2003 and the Number of enrolments of both sexes in Secondary vocational in 2005?
Offer a terse response. 1.69e+04. What is the difference between the Number of enrolments of both sexes of Secondary in 2003 and the Number of enrolments of both sexes of Secondary general in 2005?
Provide a short and direct response. -246. What is the difference between the Number of enrolments of both sexes of Secondary in 2003 and the Number of enrolments of both sexes of Secondary vocational in 2005?
Your answer should be very brief. 7909. What is the difference between the Number of enrolments of both sexes in Secondary general in 2003 and the Number of enrolments of both sexes in Secondary vocational in 2005?
Ensure brevity in your answer.  5149. What is the difference between the Number of enrolments of both sexes of Primary in 2003 and the Number of enrolments of both sexes of Secondary in 2007?
Provide a short and direct response. 7391. What is the difference between the Number of enrolments of both sexes in Primary in 2003 and the Number of enrolments of both sexes in Secondary general in 2007?
Offer a very short reply. 1.07e+04. What is the difference between the Number of enrolments of both sexes of Primary in 2003 and the Number of enrolments of both sexes of Secondary vocational in 2007?
Your response must be concise. 1.69e+04. What is the difference between the Number of enrolments of both sexes in Secondary in 2003 and the Number of enrolments of both sexes in Secondary general in 2007?
Your response must be concise. 1685. What is the difference between the Number of enrolments of both sexes of Secondary in 2003 and the Number of enrolments of both sexes of Secondary vocational in 2007?
Your answer should be compact. 7855. What is the difference between the Number of enrolments of both sexes of Secondary general in 2003 and the Number of enrolments of both sexes of Secondary vocational in 2007?
Your answer should be compact. 5095. What is the difference between the Number of enrolments of both sexes of Primary in 2004 and the Number of enrolments of both sexes of Secondary in 2005?
Provide a succinct answer. 7756. What is the difference between the Number of enrolments of both sexes in Primary in 2004 and the Number of enrolments of both sexes in Secondary general in 2005?
Keep it short and to the point. 7666. What is the difference between the Number of enrolments of both sexes of Primary in 2004 and the Number of enrolments of both sexes of Secondary vocational in 2005?
Offer a terse response. 1.58e+04. What is the difference between the Number of enrolments of both sexes in Secondary in 2004 and the Number of enrolments of both sexes in Secondary general in 2005?
Your answer should be compact. 528. What is the difference between the Number of enrolments of both sexes of Secondary in 2004 and the Number of enrolments of both sexes of Secondary vocational in 2005?
Ensure brevity in your answer.  8683. What is the difference between the Number of enrolments of both sexes in Secondary general in 2004 and the Number of enrolments of both sexes in Secondary vocational in 2005?
Make the answer very short. 8590. What is the difference between the Number of enrolments of both sexes of Primary in 2004 and the Number of enrolments of both sexes of Secondary in 2007?
Make the answer very short. 6298. What is the difference between the Number of enrolments of both sexes of Primary in 2004 and the Number of enrolments of both sexes of Secondary general in 2007?
Provide a succinct answer. 9597. What is the difference between the Number of enrolments of both sexes in Primary in 2004 and the Number of enrolments of both sexes in Secondary vocational in 2007?
Provide a short and direct response. 1.58e+04. What is the difference between the Number of enrolments of both sexes in Secondary in 2004 and the Number of enrolments of both sexes in Secondary general in 2007?
Ensure brevity in your answer.  2459. What is the difference between the Number of enrolments of both sexes in Secondary in 2004 and the Number of enrolments of both sexes in Secondary vocational in 2007?
Ensure brevity in your answer.  8629. What is the difference between the Number of enrolments of both sexes of Secondary general in 2004 and the Number of enrolments of both sexes of Secondary vocational in 2007?
Keep it short and to the point. 8536. What is the difference between the Number of enrolments of both sexes of Primary in 2005 and the Number of enrolments of both sexes of Secondary in 2007?
Offer a very short reply. 6620. What is the difference between the Number of enrolments of both sexes in Primary in 2005 and the Number of enrolments of both sexes in Secondary general in 2007?
Provide a succinct answer. 9919. What is the difference between the Number of enrolments of both sexes of Primary in 2005 and the Number of enrolments of both sexes of Secondary vocational in 2007?
Provide a short and direct response. 1.61e+04. What is the difference between the Number of enrolments of both sexes of Secondary in 2005 and the Number of enrolments of both sexes of Secondary general in 2007?
Offer a terse response. 1841. What is the difference between the Number of enrolments of both sexes in Secondary in 2005 and the Number of enrolments of both sexes in Secondary vocational in 2007?
Offer a very short reply. 8011. What is the difference between the Number of enrolments of both sexes of Secondary general in 2005 and the Number of enrolments of both sexes of Secondary vocational in 2007?
Give a very brief answer. 8101. What is the average Number of enrolments of both sexes in Primary per year?
Ensure brevity in your answer.  1.83e+04. What is the average Number of enrolments of both sexes of Secondary per year?
Offer a terse response. 1.01e+04. What is the average Number of enrolments of both sexes in Secondary general per year?
Make the answer very short. 7850. What is the average Number of enrolments of both sexes of Secondary vocational per year?
Your answer should be compact. 1237.88. In the year 1999, what is the difference between the Number of enrolments of both sexes in Primary and Number of enrolments of both sexes in Secondary?
Your response must be concise. 9119. In the year 1999, what is the difference between the Number of enrolments of both sexes in Primary and Number of enrolments of both sexes in Secondary general?
Keep it short and to the point. 1.40e+04. In the year 1999, what is the difference between the Number of enrolments of both sexes of Primary and Number of enrolments of both sexes of Secondary vocational?
Keep it short and to the point. 1.95e+04. In the year 1999, what is the difference between the Number of enrolments of both sexes in Secondary and Number of enrolments of both sexes in Secondary general?
Provide a short and direct response. 4844. In the year 1999, what is the difference between the Number of enrolments of both sexes of Secondary and Number of enrolments of both sexes of Secondary vocational?
Ensure brevity in your answer.  1.03e+04. In the year 1999, what is the difference between the Number of enrolments of both sexes in Secondary general and Number of enrolments of both sexes in Secondary vocational?
Give a very brief answer. 5495. In the year 2000, what is the difference between the Number of enrolments of both sexes in Primary and Number of enrolments of both sexes in Secondary?
Offer a terse response. 9504. In the year 2000, what is the difference between the Number of enrolments of both sexes in Primary and Number of enrolments of both sexes in Secondary general?
Keep it short and to the point. 1.26e+04. In the year 2000, what is the difference between the Number of enrolments of both sexes in Primary and Number of enrolments of both sexes in Secondary vocational?
Provide a short and direct response. 1.88e+04. In the year 2000, what is the difference between the Number of enrolments of both sexes of Secondary and Number of enrolments of both sexes of Secondary general?
Offer a terse response. 3144. In the year 2000, what is the difference between the Number of enrolments of both sexes in Secondary and Number of enrolments of both sexes in Secondary vocational?
Keep it short and to the point. 9268. In the year 2000, what is the difference between the Number of enrolments of both sexes in Secondary general and Number of enrolments of both sexes in Secondary vocational?
Keep it short and to the point. 6124. In the year 2001, what is the difference between the Number of enrolments of both sexes of Primary and Number of enrolments of both sexes of Secondary?
Offer a very short reply. 9296. In the year 2001, what is the difference between the Number of enrolments of both sexes in Primary and Number of enrolments of both sexes in Secondary general?
Make the answer very short. 1.05e+04. In the year 2001, what is the difference between the Number of enrolments of both sexes in Primary and Number of enrolments of both sexes in Secondary vocational?
Make the answer very short. 1.86e+04. In the year 2001, what is the difference between the Number of enrolments of both sexes of Secondary and Number of enrolments of both sexes of Secondary general?
Your response must be concise. 1201. In the year 2001, what is the difference between the Number of enrolments of both sexes of Secondary and Number of enrolments of both sexes of Secondary vocational?
Offer a very short reply. 9342. In the year 2001, what is the difference between the Number of enrolments of both sexes in Secondary general and Number of enrolments of both sexes in Secondary vocational?
Provide a short and direct response. 8141. In the year 2002, what is the difference between the Number of enrolments of both sexes of Primary and Number of enrolments of both sexes of Secondary?
Make the answer very short. 8210. In the year 2002, what is the difference between the Number of enrolments of both sexes of Primary and Number of enrolments of both sexes of Secondary general?
Ensure brevity in your answer.  1.13e+04. In the year 2002, what is the difference between the Number of enrolments of both sexes in Primary and Number of enrolments of both sexes in Secondary vocational?
Your answer should be very brief. 1.64e+04. In the year 2002, what is the difference between the Number of enrolments of both sexes in Secondary and Number of enrolments of both sexes in Secondary general?
Your answer should be very brief. 3063. In the year 2002, what is the difference between the Number of enrolments of both sexes of Secondary and Number of enrolments of both sexes of Secondary vocational?
Offer a very short reply. 8180. In the year 2002, what is the difference between the Number of enrolments of both sexes in Secondary general and Number of enrolments of both sexes in Secondary vocational?
Make the answer very short. 5117. In the year 2003, what is the difference between the Number of enrolments of both sexes in Primary and Number of enrolments of both sexes in Secondary?
Offer a very short reply. 9005. In the year 2003, what is the difference between the Number of enrolments of both sexes of Primary and Number of enrolments of both sexes of Secondary general?
Keep it short and to the point. 1.18e+04. In the year 2003, what is the difference between the Number of enrolments of both sexes of Primary and Number of enrolments of both sexes of Secondary vocational?
Your response must be concise. 1.69e+04. In the year 2003, what is the difference between the Number of enrolments of both sexes of Secondary and Number of enrolments of both sexes of Secondary general?
Provide a succinct answer. 2760. In the year 2003, what is the difference between the Number of enrolments of both sexes of Secondary and Number of enrolments of both sexes of Secondary vocational?
Provide a succinct answer. 7913. In the year 2003, what is the difference between the Number of enrolments of both sexes in Secondary general and Number of enrolments of both sexes in Secondary vocational?
Provide a succinct answer. 5153. In the year 2004, what is the difference between the Number of enrolments of both sexes in Primary and Number of enrolments of both sexes in Secondary?
Provide a short and direct response. 7138. In the year 2004, what is the difference between the Number of enrolments of both sexes of Primary and Number of enrolments of both sexes of Secondary general?
Offer a terse response. 7231. In the year 2004, what is the difference between the Number of enrolments of both sexes in Primary and Number of enrolments of both sexes in Secondary vocational?
Offer a terse response. 1.58e+04. In the year 2004, what is the difference between the Number of enrolments of both sexes in Secondary and Number of enrolments of both sexes in Secondary general?
Make the answer very short. 93. In the year 2004, what is the difference between the Number of enrolments of both sexes in Secondary and Number of enrolments of both sexes in Secondary vocational?
Offer a terse response. 8635. In the year 2004, what is the difference between the Number of enrolments of both sexes in Secondary general and Number of enrolments of both sexes in Secondary vocational?
Offer a very short reply. 8542. In the year 2005, what is the difference between the Number of enrolments of both sexes in Primary and Number of enrolments of both sexes in Secondary?
Offer a very short reply. 8078. In the year 2005, what is the difference between the Number of enrolments of both sexes of Primary and Number of enrolments of both sexes of Secondary general?
Your response must be concise. 7988. In the year 2005, what is the difference between the Number of enrolments of both sexes in Primary and Number of enrolments of both sexes in Secondary vocational?
Provide a short and direct response. 1.61e+04. In the year 2005, what is the difference between the Number of enrolments of both sexes in Secondary and Number of enrolments of both sexes in Secondary general?
Provide a succinct answer. -90. In the year 2005, what is the difference between the Number of enrolments of both sexes in Secondary and Number of enrolments of both sexes in Secondary vocational?
Your answer should be very brief. 8065. In the year 2005, what is the difference between the Number of enrolments of both sexes of Secondary general and Number of enrolments of both sexes of Secondary vocational?
Provide a succinct answer. 8155. In the year 2007, what is the difference between the Number of enrolments of both sexes of Primary and Number of enrolments of both sexes of Secondary?
Ensure brevity in your answer.  4690. In the year 2007, what is the difference between the Number of enrolments of both sexes in Primary and Number of enrolments of both sexes in Secondary general?
Ensure brevity in your answer.  7989. In the year 2007, what is the difference between the Number of enrolments of both sexes of Primary and Number of enrolments of both sexes of Secondary vocational?
Offer a very short reply. 1.42e+04. In the year 2007, what is the difference between the Number of enrolments of both sexes in Secondary and Number of enrolments of both sexes in Secondary general?
Provide a succinct answer. 3299. In the year 2007, what is the difference between the Number of enrolments of both sexes in Secondary and Number of enrolments of both sexes in Secondary vocational?
Your answer should be very brief. 9469. In the year 2007, what is the difference between the Number of enrolments of both sexes of Secondary general and Number of enrolments of both sexes of Secondary vocational?
Your answer should be compact. 6170. What is the ratio of the Number of enrolments of both sexes in Primary in 1999 to that in 2000?
Give a very brief answer. 1.03. What is the ratio of the Number of enrolments of both sexes of Secondary in 1999 to that in 2000?
Give a very brief answer. 1.11. What is the ratio of the Number of enrolments of both sexes in Secondary general in 1999 to that in 2000?
Keep it short and to the point. 0.9. What is the ratio of the Number of enrolments of both sexes of Secondary vocational in 1999 to that in 2000?
Your answer should be compact. 0.92. What is the ratio of the Number of enrolments of both sexes of Primary in 1999 to that in 2001?
Make the answer very short. 1.04. What is the ratio of the Number of enrolments of both sexes in Secondary in 1999 to that in 2001?
Ensure brevity in your answer.  1.1. What is the ratio of the Number of enrolments of both sexes of Secondary general in 1999 to that in 2001?
Provide a succinct answer. 0.69. What is the ratio of the Number of enrolments of both sexes in Secondary vocational in 1999 to that in 2001?
Give a very brief answer. 0.92. What is the ratio of the Number of enrolments of both sexes of Primary in 1999 to that in 2002?
Ensure brevity in your answer.  1.09. What is the ratio of the Number of enrolments of both sexes in Secondary in 1999 to that in 2002?
Provide a succinct answer. 1.08. What is the ratio of the Number of enrolments of both sexes of Secondary general in 1999 to that in 2002?
Your answer should be very brief. 0.86. What is the ratio of the Number of enrolments of both sexes of Secondary vocational in 1999 to that in 2002?
Keep it short and to the point. 0.22. What is the ratio of the Number of enrolments of both sexes in Primary in 1999 to that in 2003?
Provide a short and direct response. 1.06. What is the ratio of the Number of enrolments of both sexes in Secondary in 1999 to that in 2003?
Ensure brevity in your answer.  1.11. What is the ratio of the Number of enrolments of both sexes of Secondary general in 1999 to that in 2003?
Ensure brevity in your answer.  0.86. What is the ratio of the Number of enrolments of both sexes in Secondary vocational in 1999 to that in 2003?
Your answer should be very brief. 0.22. What is the ratio of the Number of enrolments of both sexes of Primary in 1999 to that in 2004?
Provide a succinct answer. 1.13. What is the ratio of the Number of enrolments of both sexes in Secondary in 1999 to that in 2004?
Provide a succinct answer. 1.03. What is the ratio of the Number of enrolments of both sexes in Secondary general in 1999 to that in 2004?
Ensure brevity in your answer.  0.57. What is the ratio of the Number of enrolments of both sexes in Secondary vocational in 1999 to that in 2004?
Give a very brief answer. 0.22. What is the ratio of the Number of enrolments of both sexes of Primary in 1999 to that in 2005?
Make the answer very short. 1.11. What is the ratio of the Number of enrolments of both sexes of Secondary in 1999 to that in 2005?
Provide a succinct answer. 1.1. What is the ratio of the Number of enrolments of both sexes of Secondary general in 1999 to that in 2005?
Provide a short and direct response. 0.6. What is the ratio of the Number of enrolments of both sexes in Secondary vocational in 1999 to that in 2005?
Offer a terse response. 0.22. What is the ratio of the Number of enrolments of both sexes in Primary in 1999 to that in 2007?
Make the answer very short. 1.25. What is the ratio of the Number of enrolments of both sexes of Secondary in 1999 to that in 2007?
Provide a succinct answer. 0.95. What is the ratio of the Number of enrolments of both sexes of Secondary general in 1999 to that in 2007?
Offer a terse response. 0.74. What is the ratio of the Number of enrolments of both sexes of Secondary vocational in 1999 to that in 2007?
Keep it short and to the point. 0.21. What is the ratio of the Number of enrolments of both sexes of Primary in 2000 to that in 2001?
Offer a very short reply. 1.01. What is the ratio of the Number of enrolments of both sexes in Secondary in 2000 to that in 2001?
Make the answer very short. 0.99. What is the ratio of the Number of enrolments of both sexes in Secondary general in 2000 to that in 2001?
Your answer should be very brief. 0.76. What is the ratio of the Number of enrolments of both sexes in Primary in 2000 to that in 2002?
Provide a succinct answer. 1.06. What is the ratio of the Number of enrolments of both sexes in Secondary in 2000 to that in 2002?
Your response must be concise. 0.98. What is the ratio of the Number of enrolments of both sexes in Secondary general in 2000 to that in 2002?
Keep it short and to the point. 0.95. What is the ratio of the Number of enrolments of both sexes in Secondary vocational in 2000 to that in 2002?
Your response must be concise. 0.24. What is the ratio of the Number of enrolments of both sexes of Primary in 2000 to that in 2003?
Make the answer very short. 1.03. What is the ratio of the Number of enrolments of both sexes of Secondary in 2000 to that in 2003?
Offer a terse response. 1.01. What is the ratio of the Number of enrolments of both sexes of Secondary general in 2000 to that in 2003?
Offer a very short reply. 0.95. What is the ratio of the Number of enrolments of both sexes in Secondary vocational in 2000 to that in 2003?
Make the answer very short. 0.24. What is the ratio of the Number of enrolments of both sexes of Primary in 2000 to that in 2004?
Offer a terse response. 1.09. What is the ratio of the Number of enrolments of both sexes of Secondary in 2000 to that in 2004?
Offer a terse response. 0.93. What is the ratio of the Number of enrolments of both sexes in Secondary general in 2000 to that in 2004?
Ensure brevity in your answer.  0.63. What is the ratio of the Number of enrolments of both sexes of Secondary vocational in 2000 to that in 2004?
Offer a terse response. 0.23. What is the ratio of the Number of enrolments of both sexes in Primary in 2000 to that in 2005?
Your response must be concise. 1.07. What is the ratio of the Number of enrolments of both sexes in Secondary in 2000 to that in 2005?
Ensure brevity in your answer.  0.99. What is the ratio of the Number of enrolments of both sexes of Secondary general in 2000 to that in 2005?
Your response must be concise. 0.66. What is the ratio of the Number of enrolments of both sexes of Secondary vocational in 2000 to that in 2005?
Give a very brief answer. 0.24. What is the ratio of the Number of enrolments of both sexes in Primary in 2000 to that in 2007?
Provide a short and direct response. 1.2. What is the ratio of the Number of enrolments of both sexes of Secondary in 2000 to that in 2007?
Your answer should be compact. 0.86. What is the ratio of the Number of enrolments of both sexes in Secondary general in 2000 to that in 2007?
Your answer should be compact. 0.82. What is the ratio of the Number of enrolments of both sexes in Secondary vocational in 2000 to that in 2007?
Offer a very short reply. 0.23. What is the ratio of the Number of enrolments of both sexes in Primary in 2001 to that in 2002?
Your answer should be compact. 1.05. What is the ratio of the Number of enrolments of both sexes of Secondary in 2001 to that in 2002?
Your answer should be compact. 0.98. What is the ratio of the Number of enrolments of both sexes of Secondary general in 2001 to that in 2002?
Your answer should be compact. 1.25. What is the ratio of the Number of enrolments of both sexes of Secondary vocational in 2001 to that in 2002?
Give a very brief answer. 0.24. What is the ratio of the Number of enrolments of both sexes in Primary in 2001 to that in 2003?
Ensure brevity in your answer.  1.02. What is the ratio of the Number of enrolments of both sexes in Secondary in 2001 to that in 2003?
Provide a succinct answer. 1.01. What is the ratio of the Number of enrolments of both sexes in Secondary general in 2001 to that in 2003?
Give a very brief answer. 1.25. What is the ratio of the Number of enrolments of both sexes in Secondary vocational in 2001 to that in 2003?
Your answer should be compact. 0.24. What is the ratio of the Number of enrolments of both sexes in Primary in 2001 to that in 2004?
Give a very brief answer. 1.09. What is the ratio of the Number of enrolments of both sexes of Secondary in 2001 to that in 2004?
Provide a short and direct response. 0.94. What is the ratio of the Number of enrolments of both sexes of Secondary general in 2001 to that in 2004?
Keep it short and to the point. 0.83. What is the ratio of the Number of enrolments of both sexes in Secondary vocational in 2001 to that in 2004?
Your response must be concise. 0.23. What is the ratio of the Number of enrolments of both sexes of Primary in 2001 to that in 2005?
Give a very brief answer. 1.07. What is the ratio of the Number of enrolments of both sexes of Secondary in 2001 to that in 2005?
Your answer should be compact. 1. What is the ratio of the Number of enrolments of both sexes of Secondary general in 2001 to that in 2005?
Keep it short and to the point. 0.87. What is the ratio of the Number of enrolments of both sexes in Secondary vocational in 2001 to that in 2005?
Your response must be concise. 0.24. What is the ratio of the Number of enrolments of both sexes of Primary in 2001 to that in 2007?
Offer a very short reply. 1.2. What is the ratio of the Number of enrolments of both sexes in Secondary in 2001 to that in 2007?
Ensure brevity in your answer.  0.87. What is the ratio of the Number of enrolments of both sexes in Secondary general in 2001 to that in 2007?
Your answer should be compact. 1.08. What is the ratio of the Number of enrolments of both sexes of Secondary vocational in 2001 to that in 2007?
Your answer should be very brief. 0.23. What is the ratio of the Number of enrolments of both sexes of Primary in 2002 to that in 2003?
Make the answer very short. 0.97. What is the ratio of the Number of enrolments of both sexes in Secondary in 2002 to that in 2003?
Offer a very short reply. 1.03. What is the ratio of the Number of enrolments of both sexes of Secondary vocational in 2002 to that in 2003?
Your answer should be very brief. 1.02. What is the ratio of the Number of enrolments of both sexes of Primary in 2002 to that in 2004?
Make the answer very short. 1.03. What is the ratio of the Number of enrolments of both sexes in Secondary in 2002 to that in 2004?
Offer a very short reply. 0.95. What is the ratio of the Number of enrolments of both sexes in Secondary general in 2002 to that in 2004?
Offer a terse response. 0.67. What is the ratio of the Number of enrolments of both sexes of Secondary vocational in 2002 to that in 2004?
Offer a terse response. 0.99. What is the ratio of the Number of enrolments of both sexes of Primary in 2002 to that in 2005?
Make the answer very short. 1.02. What is the ratio of the Number of enrolments of both sexes of Secondary in 2002 to that in 2005?
Provide a short and direct response. 1.01. What is the ratio of the Number of enrolments of both sexes in Secondary general in 2002 to that in 2005?
Give a very brief answer. 0.69. What is the ratio of the Number of enrolments of both sexes in Secondary vocational in 2002 to that in 2005?
Provide a succinct answer. 1.01. What is the ratio of the Number of enrolments of both sexes of Primary in 2002 to that in 2007?
Provide a short and direct response. 1.14. What is the ratio of the Number of enrolments of both sexes of Secondary in 2002 to that in 2007?
Ensure brevity in your answer.  0.88. What is the ratio of the Number of enrolments of both sexes of Secondary general in 2002 to that in 2007?
Give a very brief answer. 0.86. What is the ratio of the Number of enrolments of both sexes in Secondary vocational in 2002 to that in 2007?
Give a very brief answer. 0.98. What is the ratio of the Number of enrolments of both sexes of Primary in 2003 to that in 2004?
Ensure brevity in your answer.  1.06. What is the ratio of the Number of enrolments of both sexes of Secondary in 2003 to that in 2004?
Ensure brevity in your answer.  0.93. What is the ratio of the Number of enrolments of both sexes in Secondary general in 2003 to that in 2004?
Offer a very short reply. 0.67. What is the ratio of the Number of enrolments of both sexes of Secondary vocational in 2003 to that in 2004?
Give a very brief answer. 0.97. What is the ratio of the Number of enrolments of both sexes in Primary in 2003 to that in 2005?
Give a very brief answer. 1.04. What is the ratio of the Number of enrolments of both sexes of Secondary general in 2003 to that in 2005?
Offer a very short reply. 0.7. What is the ratio of the Number of enrolments of both sexes of Primary in 2003 to that in 2007?
Your answer should be very brief. 1.17. What is the ratio of the Number of enrolments of both sexes in Secondary in 2003 to that in 2007?
Your response must be concise. 0.86. What is the ratio of the Number of enrolments of both sexes of Secondary general in 2003 to that in 2007?
Offer a very short reply. 0.86. What is the ratio of the Number of enrolments of both sexes in Secondary vocational in 2003 to that in 2007?
Offer a very short reply. 0.97. What is the ratio of the Number of enrolments of both sexes of Secondary in 2004 to that in 2005?
Keep it short and to the point. 1.06. What is the ratio of the Number of enrolments of both sexes of Secondary general in 2004 to that in 2005?
Your answer should be compact. 1.04. What is the ratio of the Number of enrolments of both sexes of Secondary vocational in 2004 to that in 2005?
Ensure brevity in your answer.  1.03. What is the ratio of the Number of enrolments of both sexes of Primary in 2004 to that in 2007?
Give a very brief answer. 1.1. What is the ratio of the Number of enrolments of both sexes in Secondary in 2004 to that in 2007?
Offer a very short reply. 0.93. What is the ratio of the Number of enrolments of both sexes of Secondary general in 2004 to that in 2007?
Your answer should be very brief. 1.3. What is the ratio of the Number of enrolments of both sexes in Primary in 2005 to that in 2007?
Your response must be concise. 1.12. What is the ratio of the Number of enrolments of both sexes in Secondary in 2005 to that in 2007?
Provide a short and direct response. 0.87. What is the ratio of the Number of enrolments of both sexes of Secondary general in 2005 to that in 2007?
Your answer should be very brief. 1.24. What is the ratio of the Number of enrolments of both sexes in Secondary vocational in 2005 to that in 2007?
Provide a succinct answer. 0.97. What is the difference between the highest and the second highest Number of enrolments of both sexes in Primary?
Give a very brief answer. 655. What is the difference between the highest and the second highest Number of enrolments of both sexes in Secondary?
Your response must be concise. 519. What is the difference between the highest and the second highest Number of enrolments of both sexes in Secondary general?
Your response must be concise. 435. What is the difference between the highest and the lowest Number of enrolments of both sexes of Primary?
Your response must be concise. 3910. What is the difference between the highest and the lowest Number of enrolments of both sexes of Secondary?
Offer a terse response. 1614. What is the difference between the highest and the lowest Number of enrolments of both sexes in Secondary general?
Make the answer very short. 4430. What is the difference between the highest and the lowest Number of enrolments of both sexes of Secondary vocational?
Your answer should be compact. 1389. 